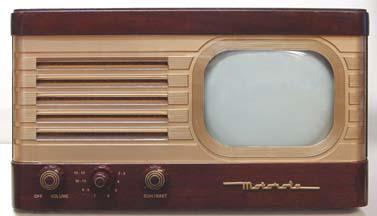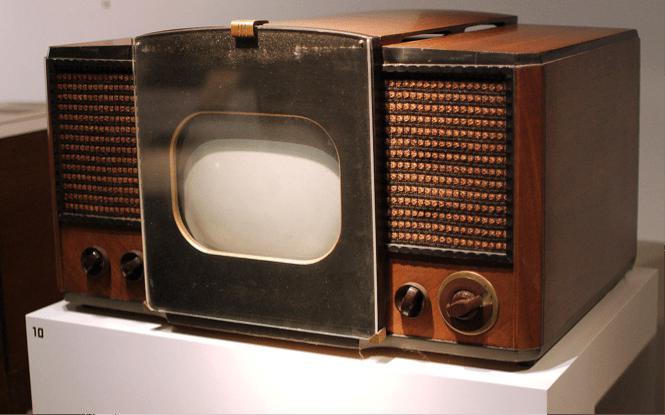The first image is the image on the left, the second image is the image on the right. Examine the images to the left and right. Is the description "There is one person next to a television" accurate? Answer yes or no. No. The first image is the image on the left, the second image is the image on the right. Evaluate the accuracy of this statement regarding the images: "In one of the images, there is a single person by the TV.". Is it true? Answer yes or no. No. 